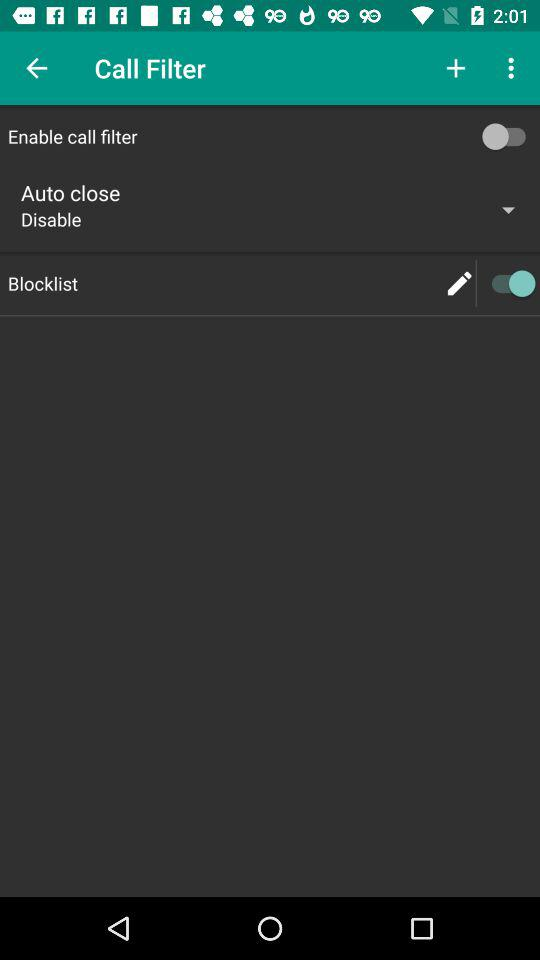What is the name of the application?
When the provided information is insufficient, respond with <no answer>. <no answer> 